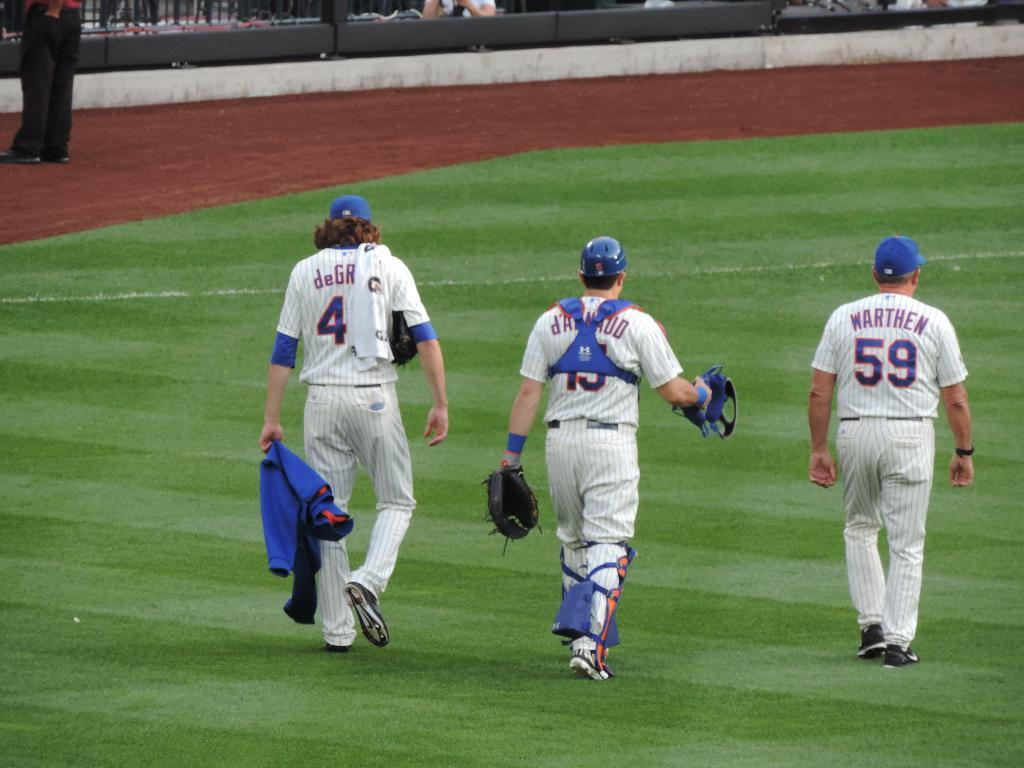<image>
Relay a brief, clear account of the picture shown. A player in a baseball uniform that says Warthen on the back walks to the right of two other players. 